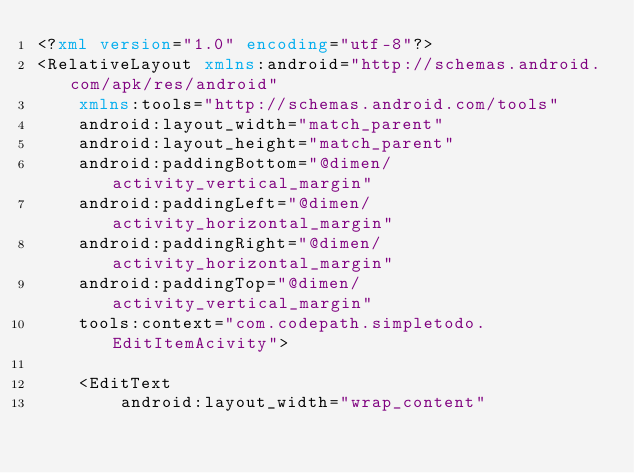<code> <loc_0><loc_0><loc_500><loc_500><_XML_><?xml version="1.0" encoding="utf-8"?>
<RelativeLayout xmlns:android="http://schemas.android.com/apk/res/android"
    xmlns:tools="http://schemas.android.com/tools"
    android:layout_width="match_parent"
    android:layout_height="match_parent"
    android:paddingBottom="@dimen/activity_vertical_margin"
    android:paddingLeft="@dimen/activity_horizontal_margin"
    android:paddingRight="@dimen/activity_horizontal_margin"
    android:paddingTop="@dimen/activity_vertical_margin"
    tools:context="com.codepath.simpletodo.EditItemAcivity">

    <EditText
        android:layout_width="wrap_content"</code> 